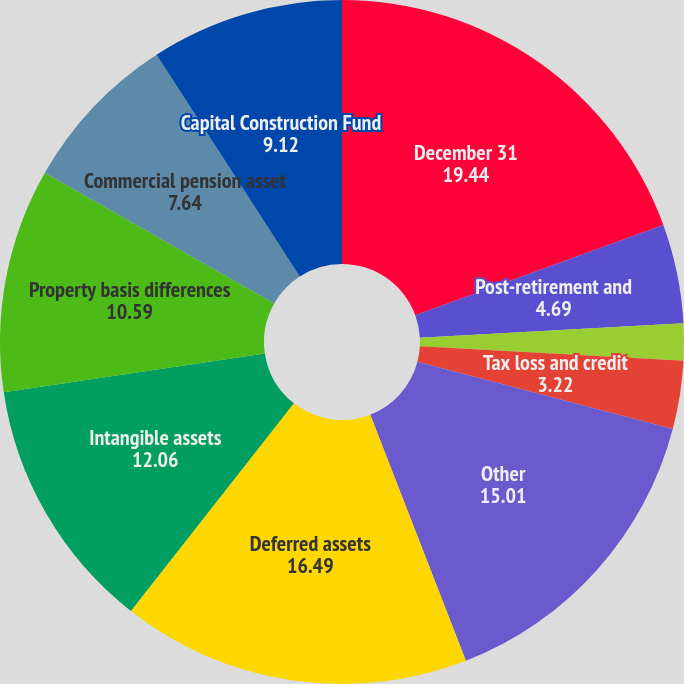<chart> <loc_0><loc_0><loc_500><loc_500><pie_chart><fcel>December 31<fcel>Post-retirement and<fcel>A-12 termination<fcel>Tax loss and credit<fcel>Other<fcel>Deferred assets<fcel>Intangible assets<fcel>Property basis differences<fcel>Commercial pension asset<fcel>Capital Construction Fund<nl><fcel>19.44%<fcel>4.69%<fcel>1.74%<fcel>3.22%<fcel>15.01%<fcel>16.49%<fcel>12.06%<fcel>10.59%<fcel>7.64%<fcel>9.12%<nl></chart> 